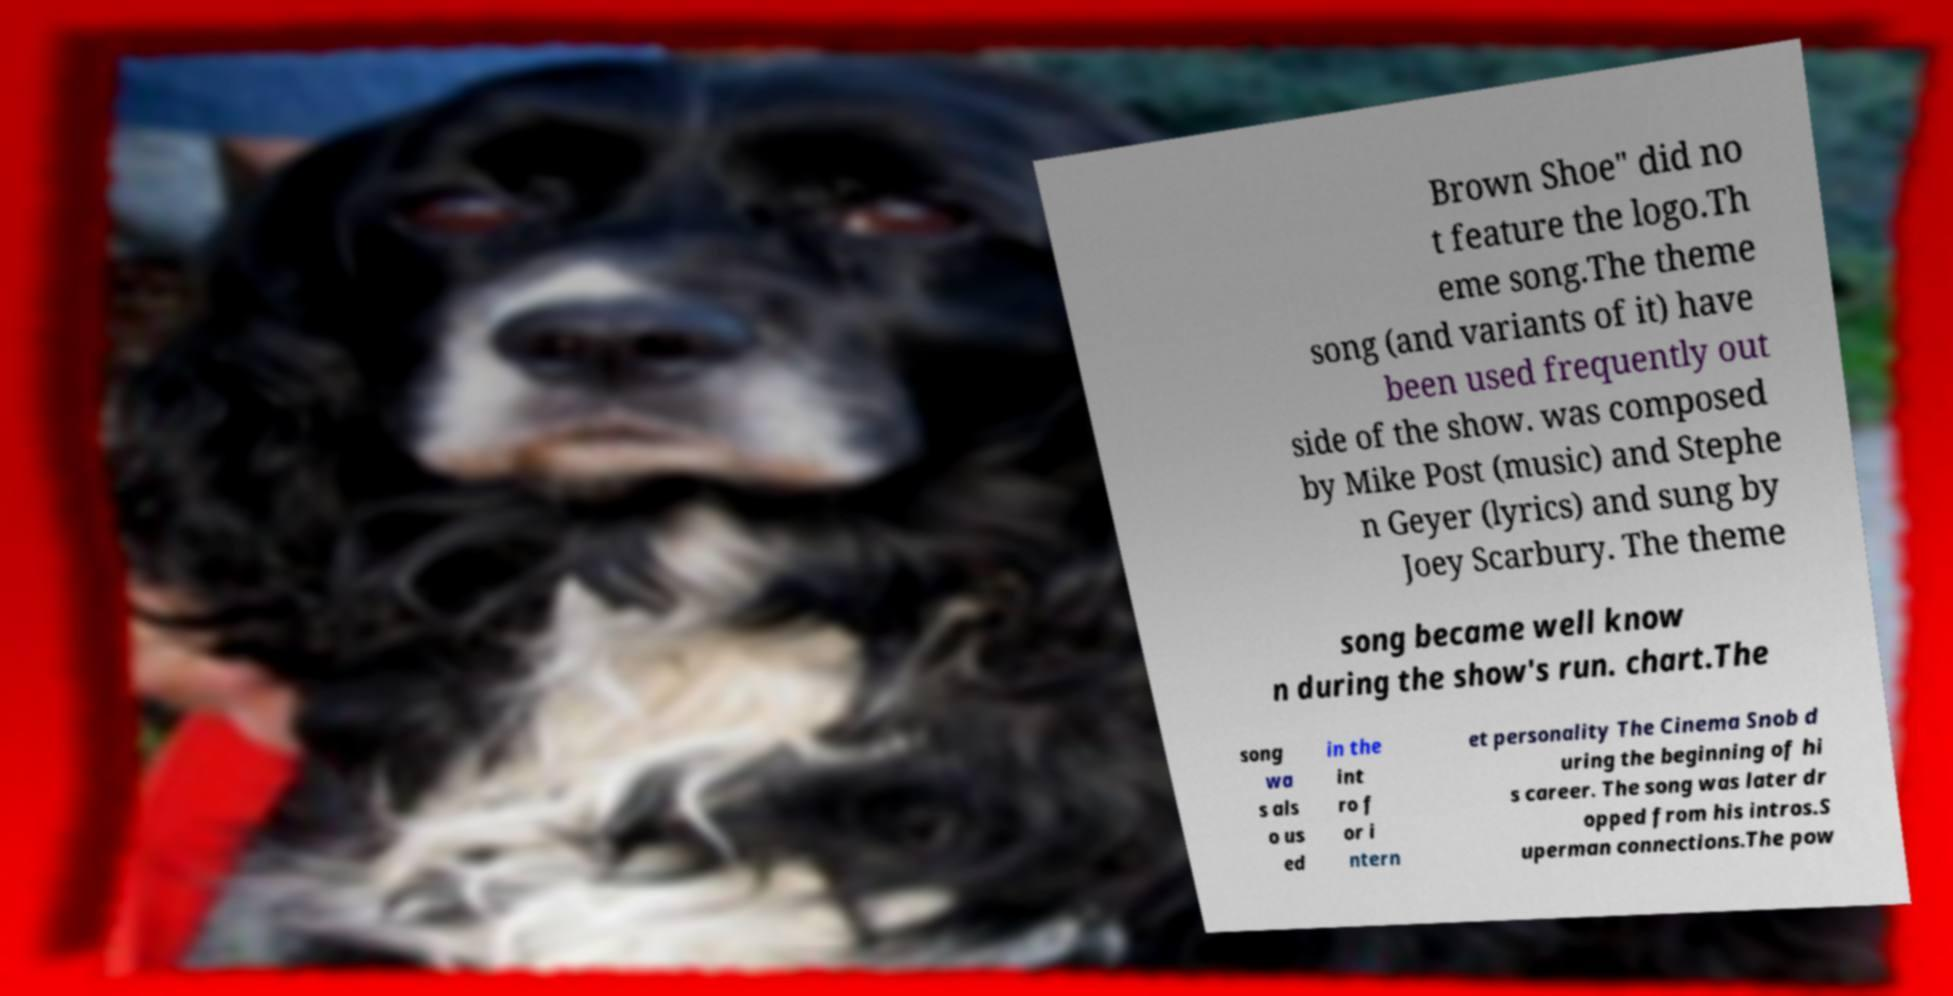What messages or text are displayed in this image? I need them in a readable, typed format. Brown Shoe" did no t feature the logo.Th eme song.The theme song (and variants of it) have been used frequently out side of the show. was composed by Mike Post (music) and Stephe n Geyer (lyrics) and sung by Joey Scarbury. The theme song became well know n during the show's run. chart.The song wa s als o us ed in the int ro f or i ntern et personality The Cinema Snob d uring the beginning of hi s career. The song was later dr opped from his intros.S uperman connections.The pow 